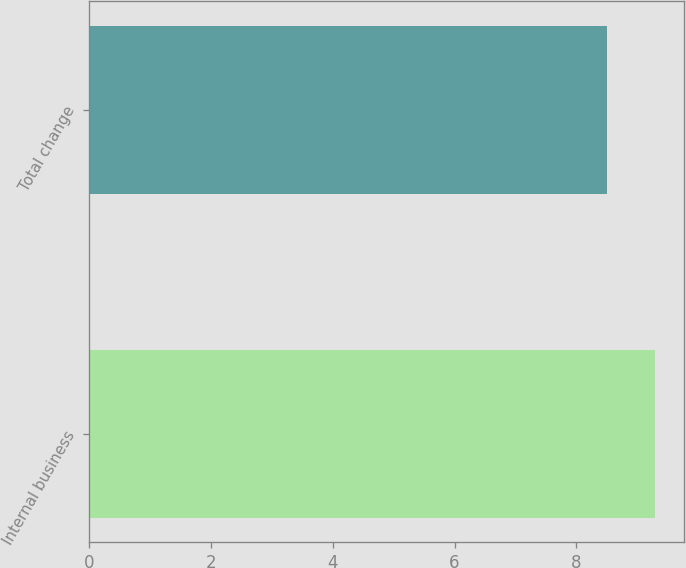<chart> <loc_0><loc_0><loc_500><loc_500><bar_chart><fcel>Internal business<fcel>Total change<nl><fcel>9.3<fcel>8.5<nl></chart> 